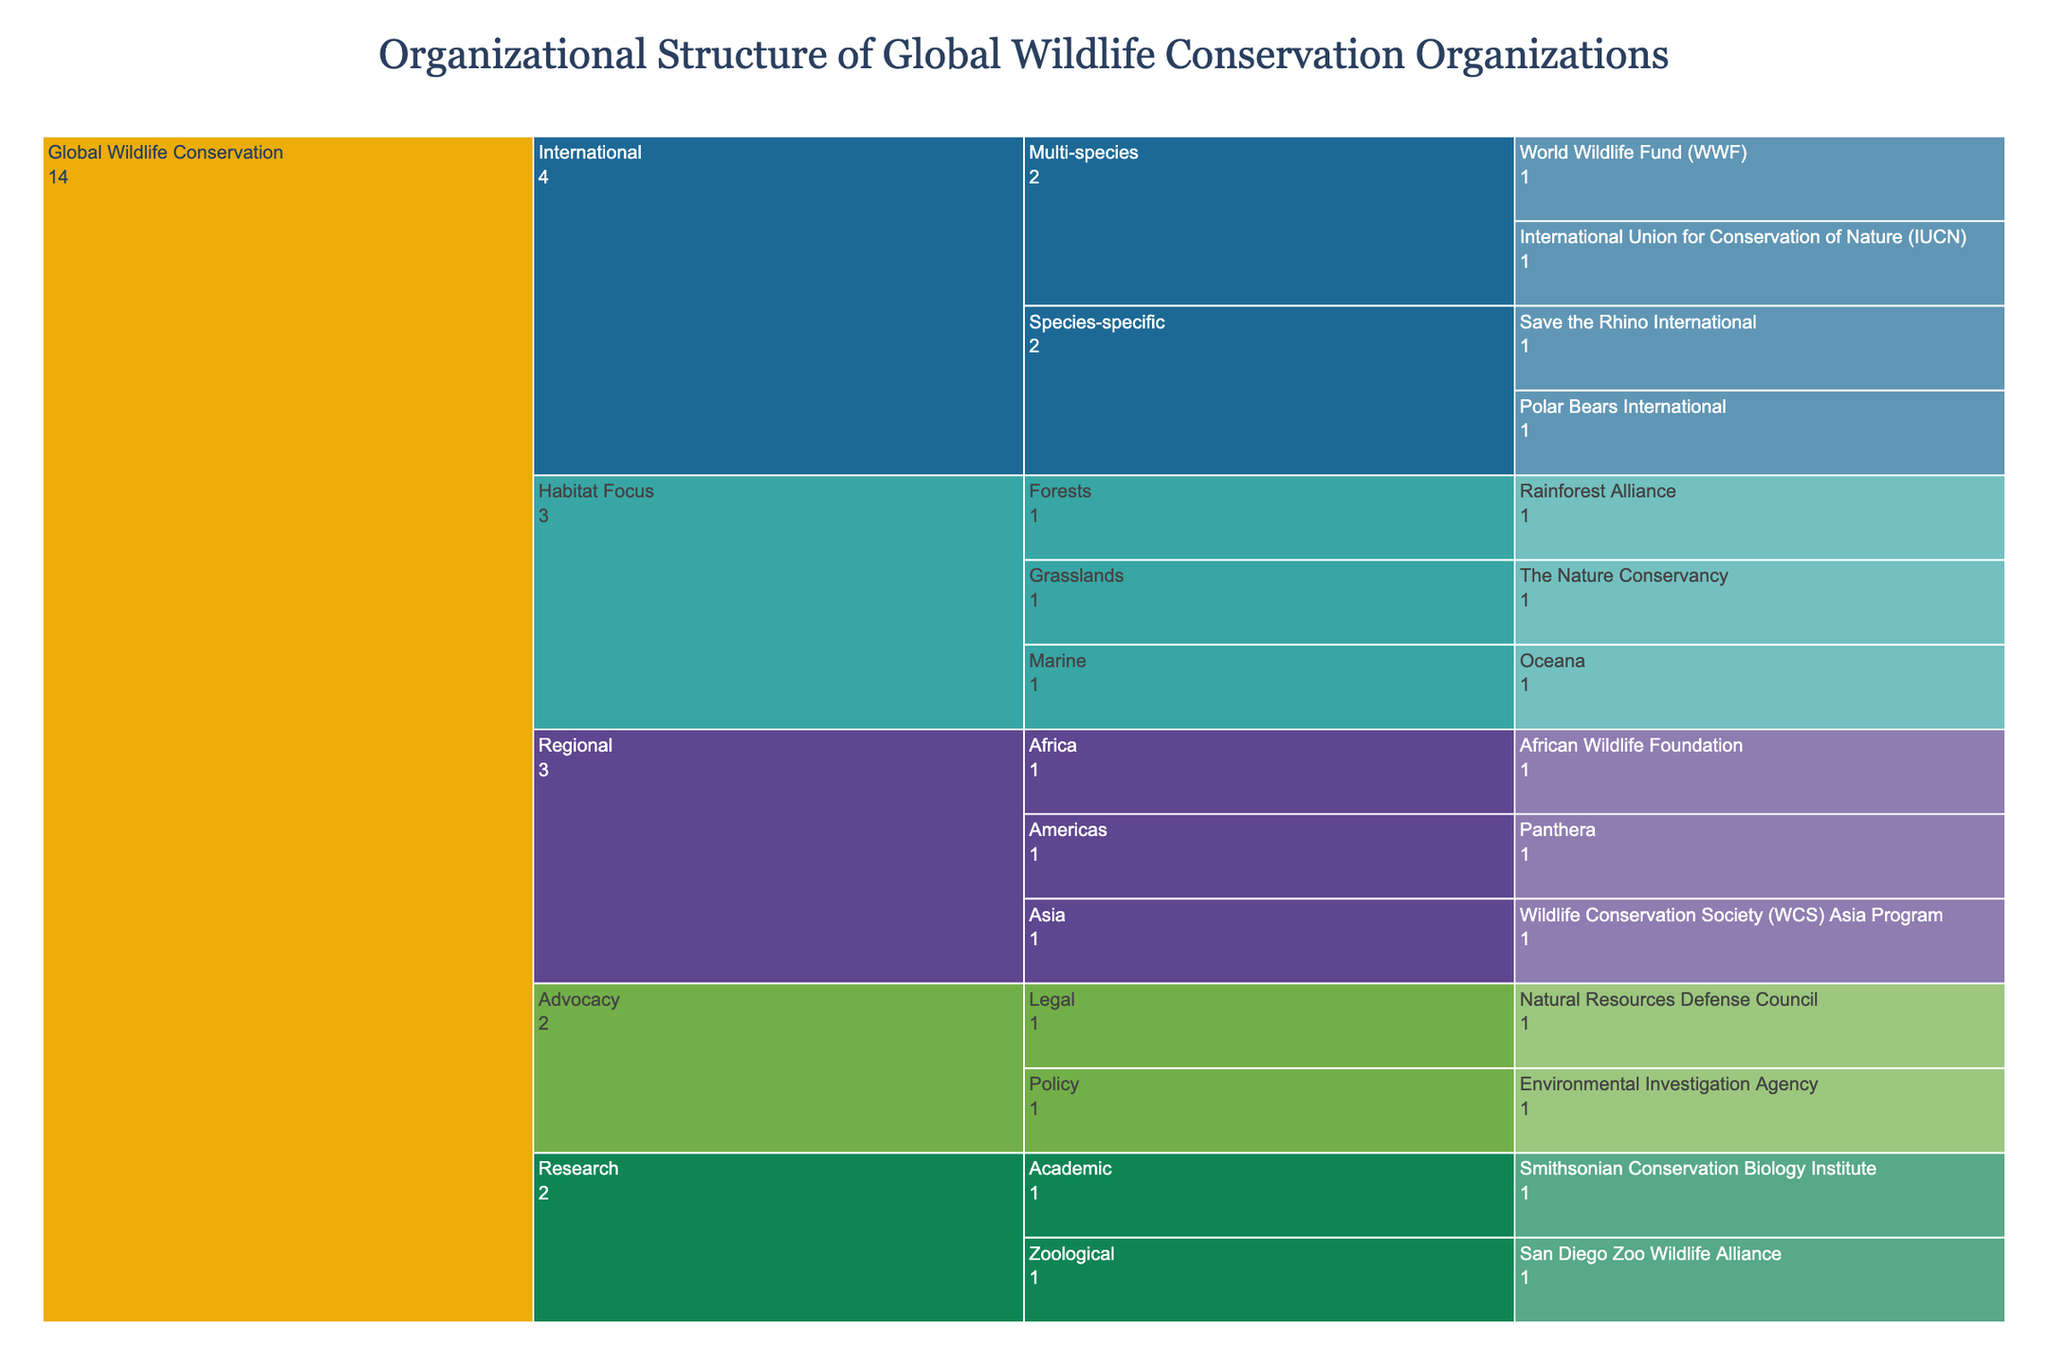What's the title of the figure? The title is shown at the top of the figure, which reads 'Organizational Structure of Global Wildlife Conservation Organizations'.
Answer: Organizational Structure of Global Wildlife Conservation Organizations How many main categories are there in the figure? There are five main categories under 'Global Wildlife Conservation'. These categories are 'International', 'Regional', 'Habitat Focus', 'Research', and 'Advocacy'.
Answer: Five Which organization falls under both 'Habitat Focus' and 'Marine' categories? By following the "Habitat Focus" path and then branching into the "Marine" subcategory, we see that the organization listed is 'Oceana'.
Answer: Oceana How many organizations are under the 'International' category? Expanding the 'International' category reveals two subcategories: 'Multi-species' and 'Species-specific'. The 'Multi-species' subcategory has 2 organizations (WWF and IUCN), and 'Species-specific' also has 2 organizations (Save the Rhino International and Polar Bears International). So, 2 + 2 = 4.
Answer: Four List the organizations that focus on 'Regional' conservation efforts. The 'Regional' category branches into 'Africa', 'Asia', and 'Americas'. Following each branch, we find: African Wildlife Foundation (Africa), Wildlife Conservation Society (WCS) Asia Program (Asia), and Panthera (Americas).
Answer: African Wildlife Foundation, Wildlife Conservation Society (WCS) Asia Program, Panthera Which category under 'Global Wildlife Conservation' has the most organizations, and how many does it have? By counting the organizations in each main category: 'International' (4), 'Regional' (3), 'Habitat Focus' (3), 'Research' (2), 'Advocacy' (2). The 'International' category has the most organizations with a count of 4.
Answer: International, Four Compare the number of organizations focused on 'Marine' habitats versus 'Forests' habitats. Under 'Habitat Focus', the 'Marine' subgroup has 1 organization (Oceana), while the 'Forests' subgroup also has 1 organization (Rainforest Alliance). Both have an equal number of organizations.
Answer: Equal (1 each) How are research-oriented organizations distributed within the 'Research' category? The 'Research' category splits into 'Zoological' and 'Academic'. Examining each, we see the 'Zoological' branch lists the 'San Diego Zoo Wildlife Alliance' and the 'Academic' branch lists the 'Smithsonian Conservation Biology Institute'.
Answer: San Diego Zoo Wildlife Alliance (Zoological), Smithsonian Conservation Biology Institute (Academic) Which organization is listed under 'Advocacy' for 'Policy'? By following the 'Advocacy' path and then branching into 'Policy', the listed organization is 'Environmental Investigation Agency'.
Answer: Environmental Investigation Agency 